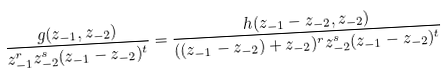<formula> <loc_0><loc_0><loc_500><loc_500>\frac { g ( z _ { - 1 } , z _ { - 2 } ) } { z _ { - 1 } ^ { r } z _ { - 2 } ^ { s } ( z _ { - 1 } - z _ { - 2 } ) ^ { t } } = \frac { h ( z _ { - 1 } - z _ { - 2 } , z _ { - 2 } ) } { ( ( z _ { - 1 } - z _ { - 2 } ) + z _ { - 2 } ) ^ { r } z _ { - 2 } ^ { s } ( z _ { - 1 } - z _ { - 2 } ) ^ { t } }</formula> 